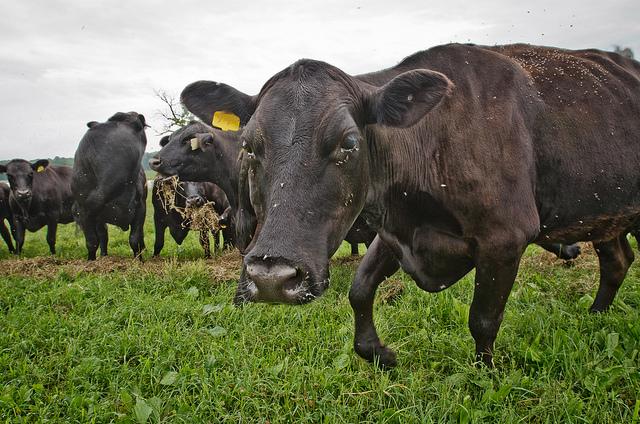What color is the spot on the cow's head?
Answer briefly. Brown. What color is the tag?
Be succinct. Yellow. What is in the middle of the picture?
Answer briefly. Cow. Are these animals domesticated?
Keep it brief. Yes. 